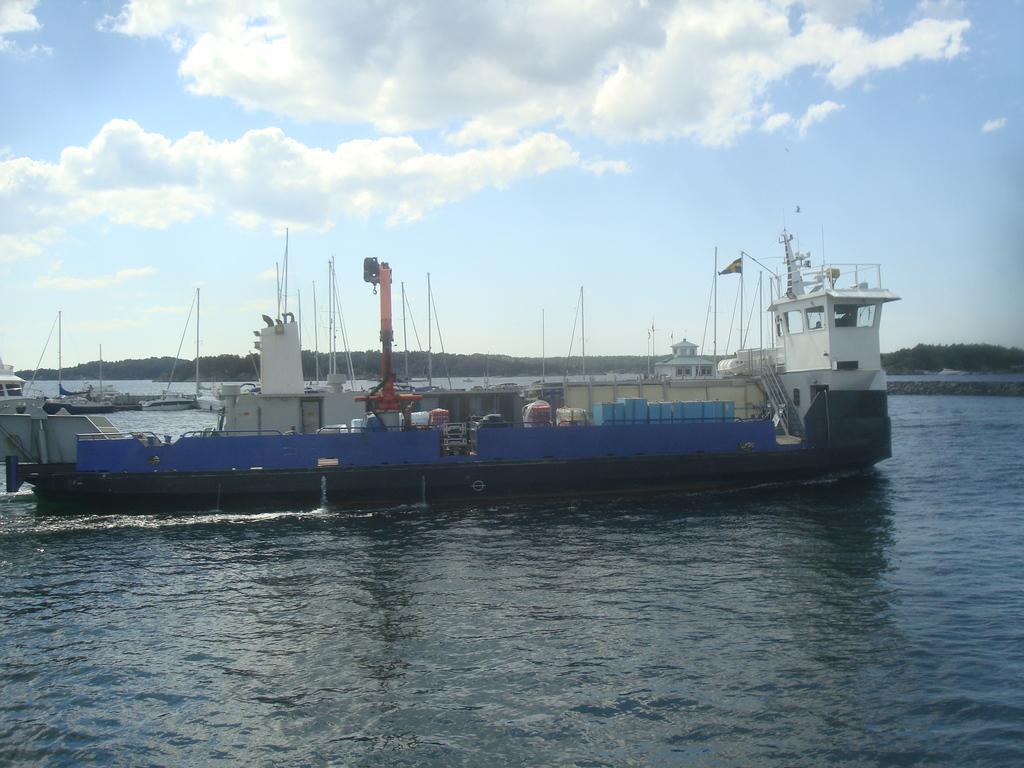In one or two sentences, can you explain what this image depicts? As we can see in the image there is water and boats. In the background there are trees. At the top there is sky and clouds. 